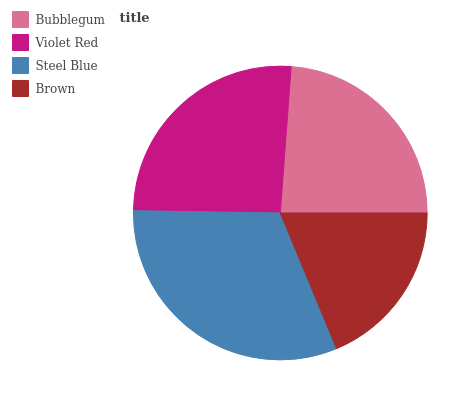Is Brown the minimum?
Answer yes or no. Yes. Is Steel Blue the maximum?
Answer yes or no. Yes. Is Violet Red the minimum?
Answer yes or no. No. Is Violet Red the maximum?
Answer yes or no. No. Is Violet Red greater than Bubblegum?
Answer yes or no. Yes. Is Bubblegum less than Violet Red?
Answer yes or no. Yes. Is Bubblegum greater than Violet Red?
Answer yes or no. No. Is Violet Red less than Bubblegum?
Answer yes or no. No. Is Violet Red the high median?
Answer yes or no. Yes. Is Bubblegum the low median?
Answer yes or no. Yes. Is Brown the high median?
Answer yes or no. No. Is Steel Blue the low median?
Answer yes or no. No. 